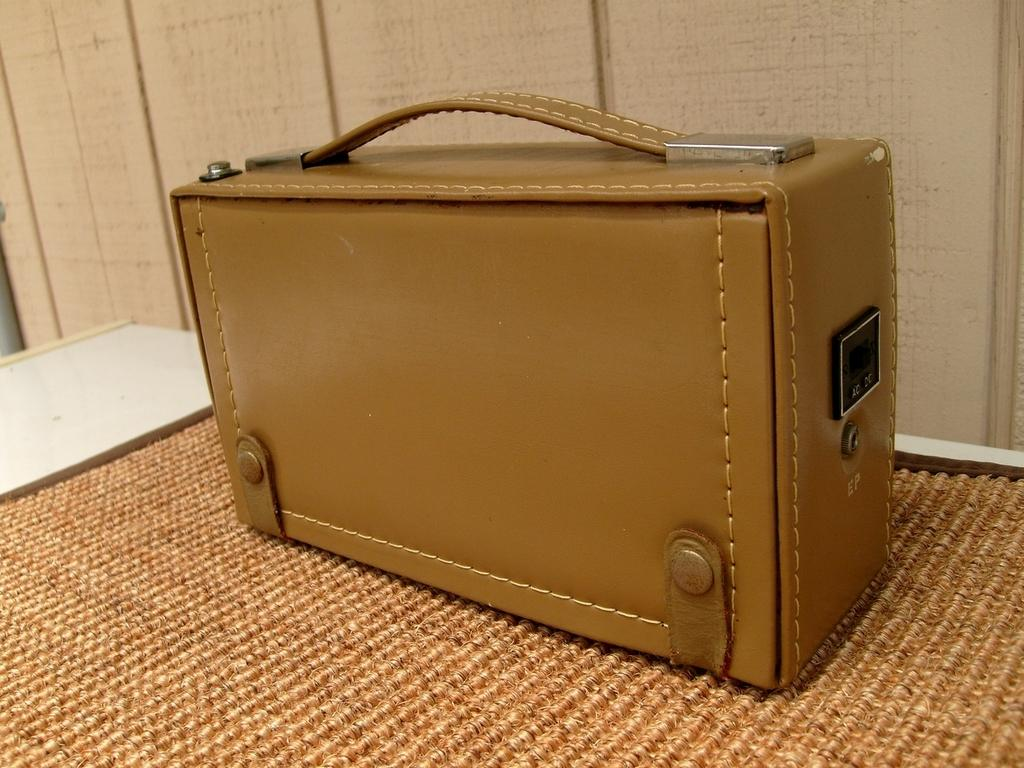What object is visible in the image that people might use for traveling? There is a suitcase in the image that people might use for traveling. Where is the suitcase placed in the image? The suitcase is placed on a mat in the image. What is the mat placed on in the image? The mat is on a table in the image. How does the tramp interact with the suitcase in the image? There is no tramp present in the image, so it is not possible to answer that question. 